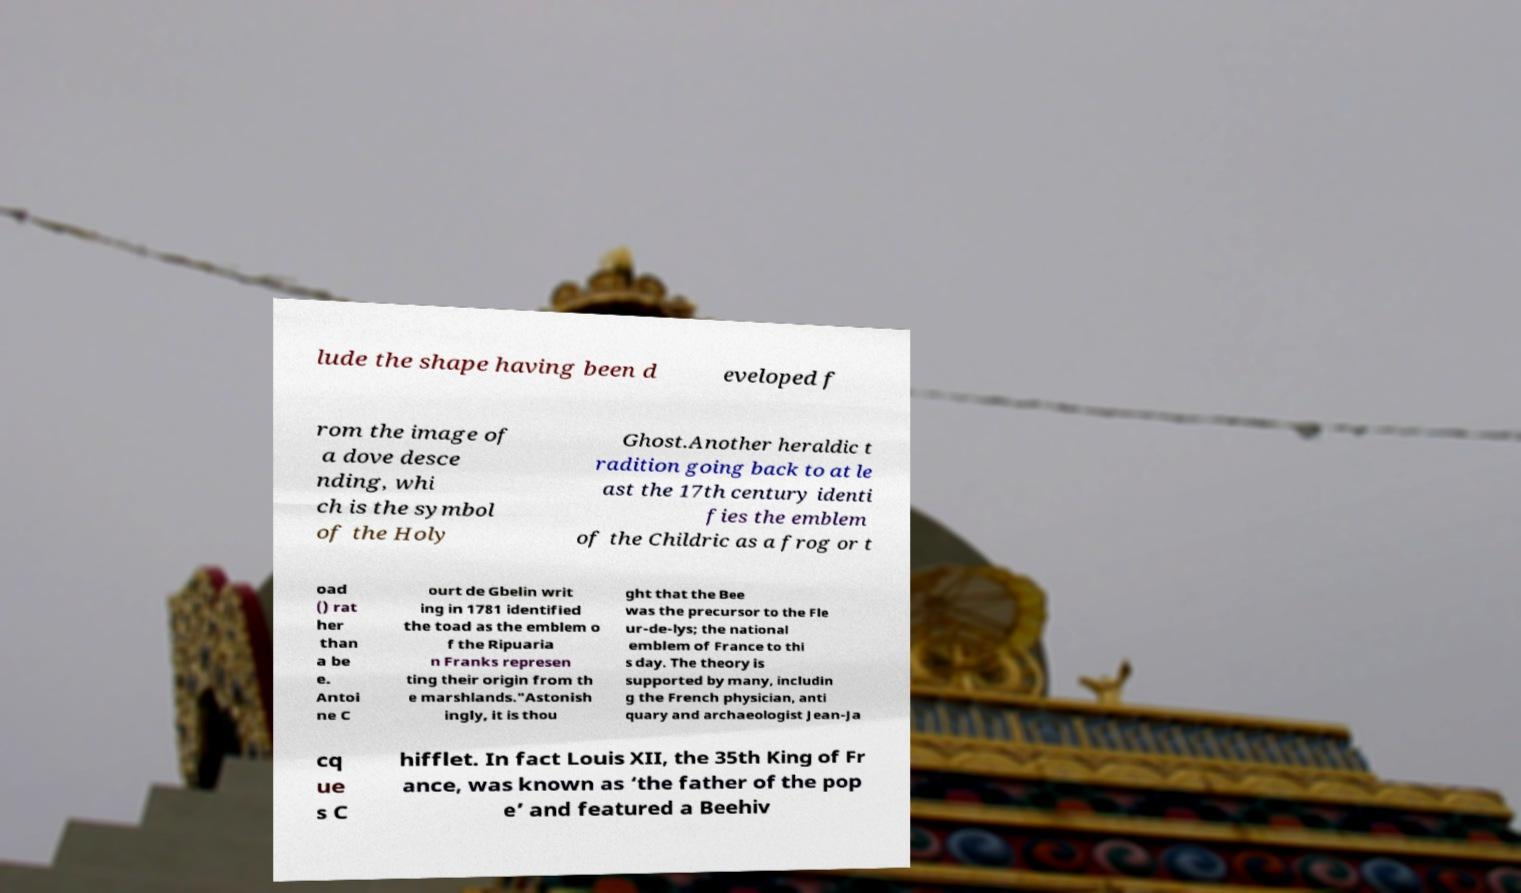Could you extract and type out the text from this image? lude the shape having been d eveloped f rom the image of a dove desce nding, whi ch is the symbol of the Holy Ghost.Another heraldic t radition going back to at le ast the 17th century identi fies the emblem of the Childric as a frog or t oad () rat her than a be e. Antoi ne C ourt de Gbelin writ ing in 1781 identified the toad as the emblem o f the Ripuaria n Franks represen ting their origin from th e marshlands."Astonish ingly, it is thou ght that the Bee was the precursor to the Fle ur-de-lys; the national emblem of France to thi s day. The theory is supported by many, includin g the French physician, anti quary and archaeologist Jean-Ja cq ue s C hifflet. In fact Louis XII, the 35th King of Fr ance, was known as ‘the father of the pop e’ and featured a Beehiv 